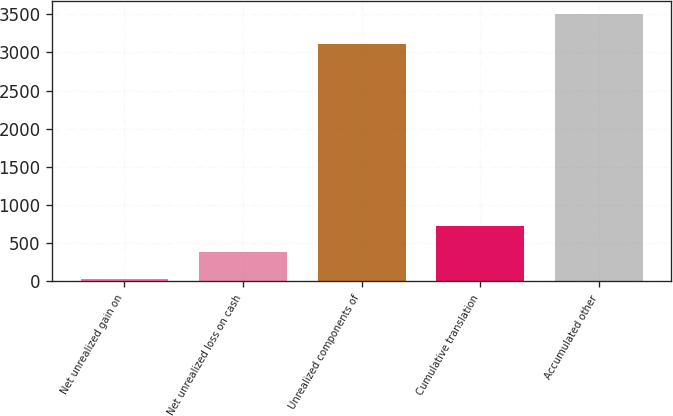Convert chart to OTSL. <chart><loc_0><loc_0><loc_500><loc_500><bar_chart><fcel>Net unrealized gain on<fcel>Net unrealized loss on cash<fcel>Unrealized components of<fcel>Cumulative translation<fcel>Accumulated other<nl><fcel>37<fcel>383.1<fcel>3109<fcel>729.2<fcel>3498<nl></chart> 